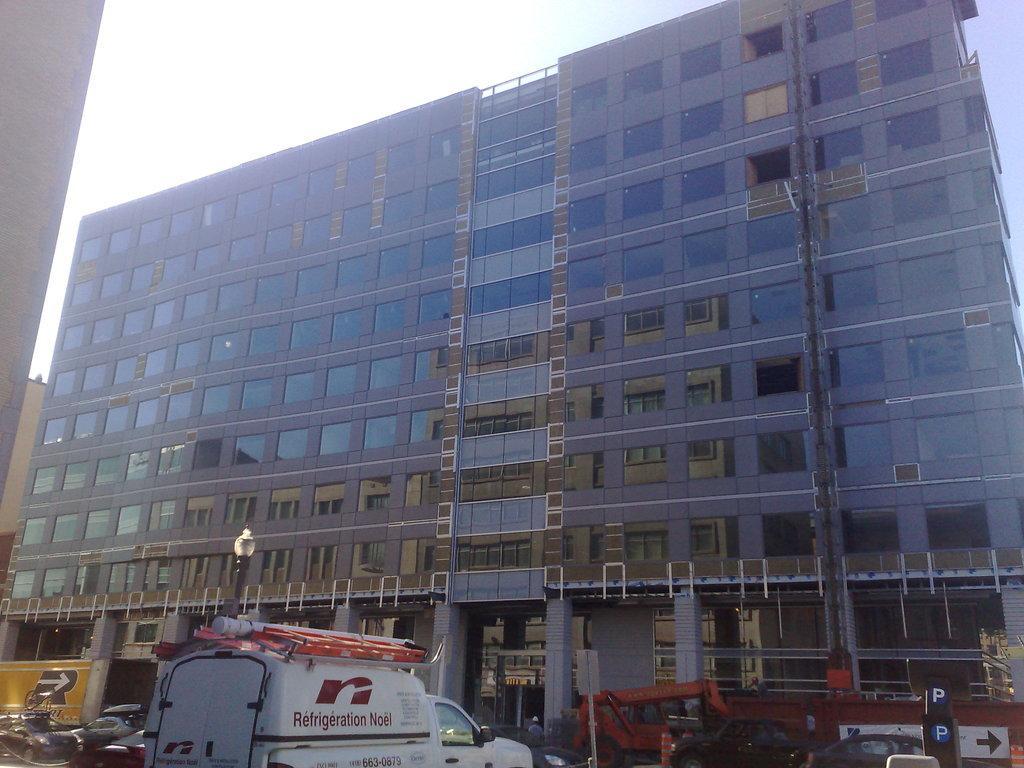Describe this image in one or two sentences. In this image we can see one big glass building, so many vehicles in front of the building, so many objects are on the surface, one person near to the building, one yellow, red sign boards are there, one light, one name board attached to the building and at the top there is the sky. 